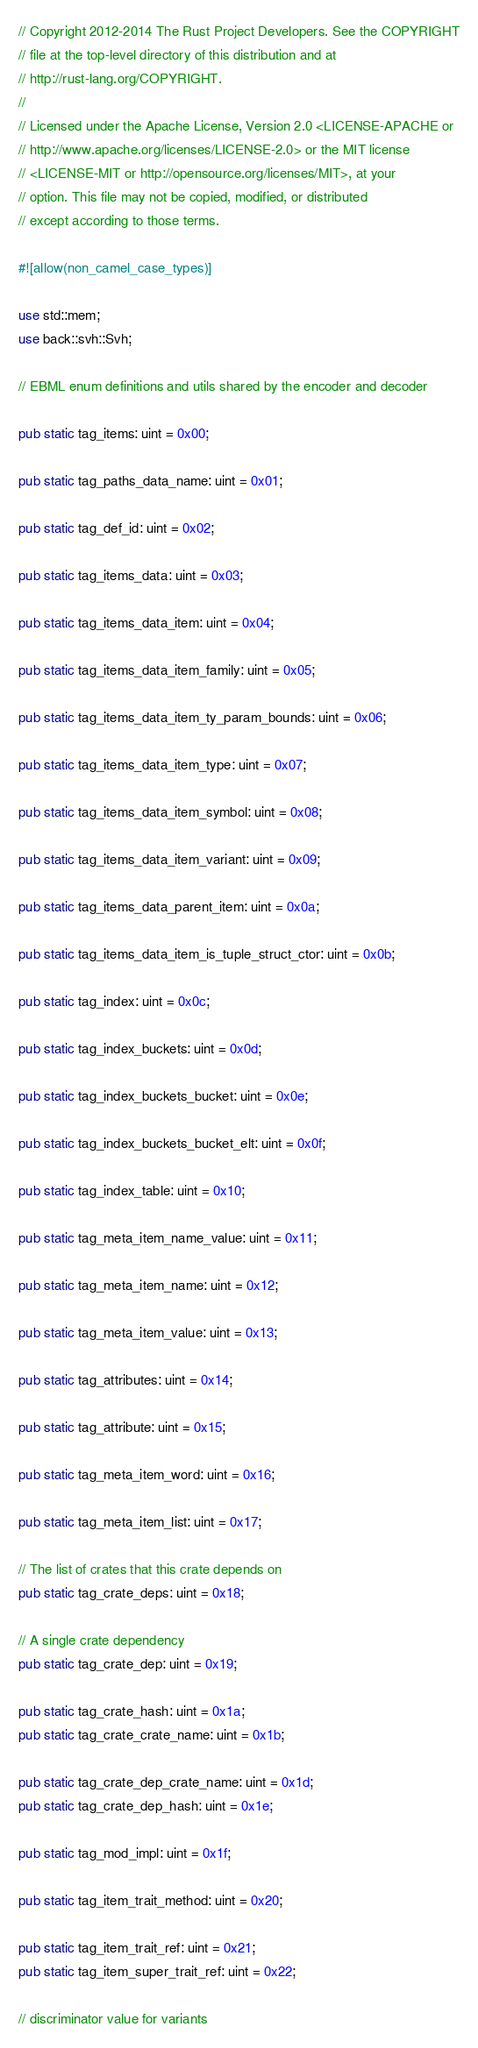Convert code to text. <code><loc_0><loc_0><loc_500><loc_500><_Rust_>// Copyright 2012-2014 The Rust Project Developers. See the COPYRIGHT
// file at the top-level directory of this distribution and at
// http://rust-lang.org/COPYRIGHT.
//
// Licensed under the Apache License, Version 2.0 <LICENSE-APACHE or
// http://www.apache.org/licenses/LICENSE-2.0> or the MIT license
// <LICENSE-MIT or http://opensource.org/licenses/MIT>, at your
// option. This file may not be copied, modified, or distributed
// except according to those terms.

#![allow(non_camel_case_types)]

use std::mem;
use back::svh::Svh;

// EBML enum definitions and utils shared by the encoder and decoder

pub static tag_items: uint = 0x00;

pub static tag_paths_data_name: uint = 0x01;

pub static tag_def_id: uint = 0x02;

pub static tag_items_data: uint = 0x03;

pub static tag_items_data_item: uint = 0x04;

pub static tag_items_data_item_family: uint = 0x05;

pub static tag_items_data_item_ty_param_bounds: uint = 0x06;

pub static tag_items_data_item_type: uint = 0x07;

pub static tag_items_data_item_symbol: uint = 0x08;

pub static tag_items_data_item_variant: uint = 0x09;

pub static tag_items_data_parent_item: uint = 0x0a;

pub static tag_items_data_item_is_tuple_struct_ctor: uint = 0x0b;

pub static tag_index: uint = 0x0c;

pub static tag_index_buckets: uint = 0x0d;

pub static tag_index_buckets_bucket: uint = 0x0e;

pub static tag_index_buckets_bucket_elt: uint = 0x0f;

pub static tag_index_table: uint = 0x10;

pub static tag_meta_item_name_value: uint = 0x11;

pub static tag_meta_item_name: uint = 0x12;

pub static tag_meta_item_value: uint = 0x13;

pub static tag_attributes: uint = 0x14;

pub static tag_attribute: uint = 0x15;

pub static tag_meta_item_word: uint = 0x16;

pub static tag_meta_item_list: uint = 0x17;

// The list of crates that this crate depends on
pub static tag_crate_deps: uint = 0x18;

// A single crate dependency
pub static tag_crate_dep: uint = 0x19;

pub static tag_crate_hash: uint = 0x1a;
pub static tag_crate_crate_name: uint = 0x1b;

pub static tag_crate_dep_crate_name: uint = 0x1d;
pub static tag_crate_dep_hash: uint = 0x1e;

pub static tag_mod_impl: uint = 0x1f;

pub static tag_item_trait_method: uint = 0x20;

pub static tag_item_trait_ref: uint = 0x21;
pub static tag_item_super_trait_ref: uint = 0x22;

// discriminator value for variants</code> 